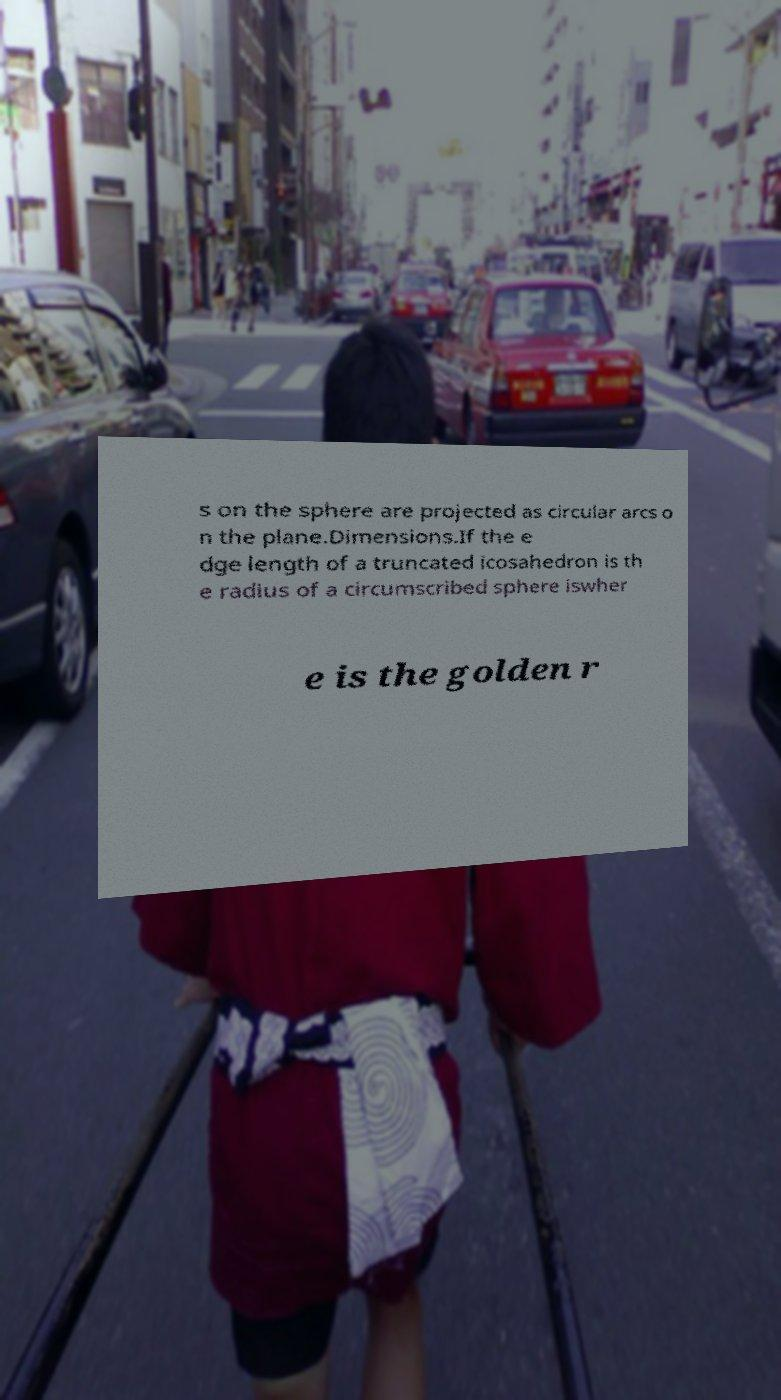Please identify and transcribe the text found in this image. s on the sphere are projected as circular arcs o n the plane.Dimensions.If the e dge length of a truncated icosahedron is th e radius of a circumscribed sphere iswher e is the golden r 